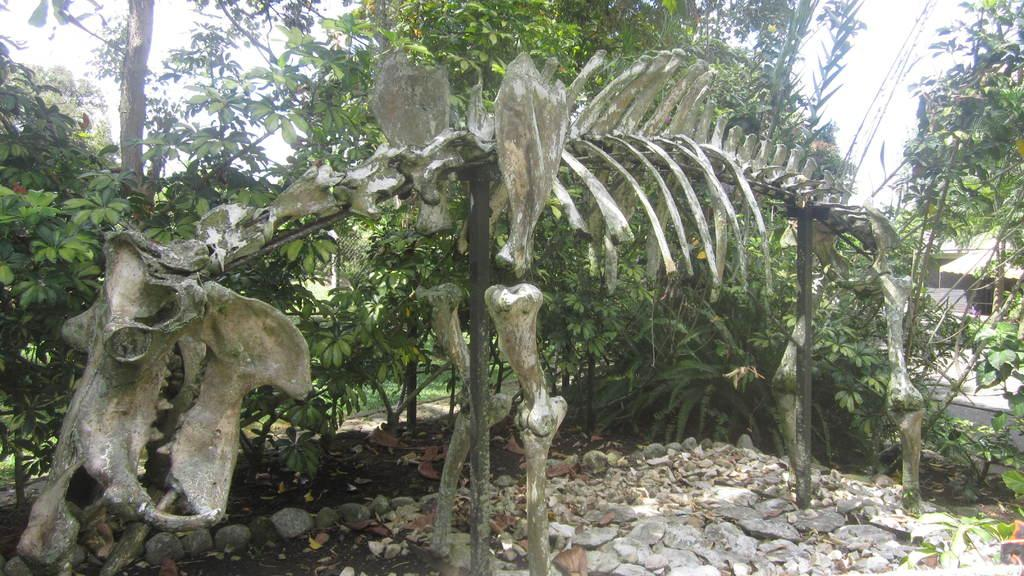What is placed on the stones in the image? There is a skeleton of an animal placed on stones in the image. What type of vegetation can be seen in the image? Dry leaves, trees, and grass are present in the image. What other structures or objects can be seen in the image? Wires and a tent are visible in the image. What is visible in the background of the image? The sky is visible in the background of the image. What color is the orange that the ladybug is sitting on in the image? There is no orange or ladybug present in the image. Can you see an airplane flying in the sky in the image? No, there is no airplane visible in the sky in the image. 